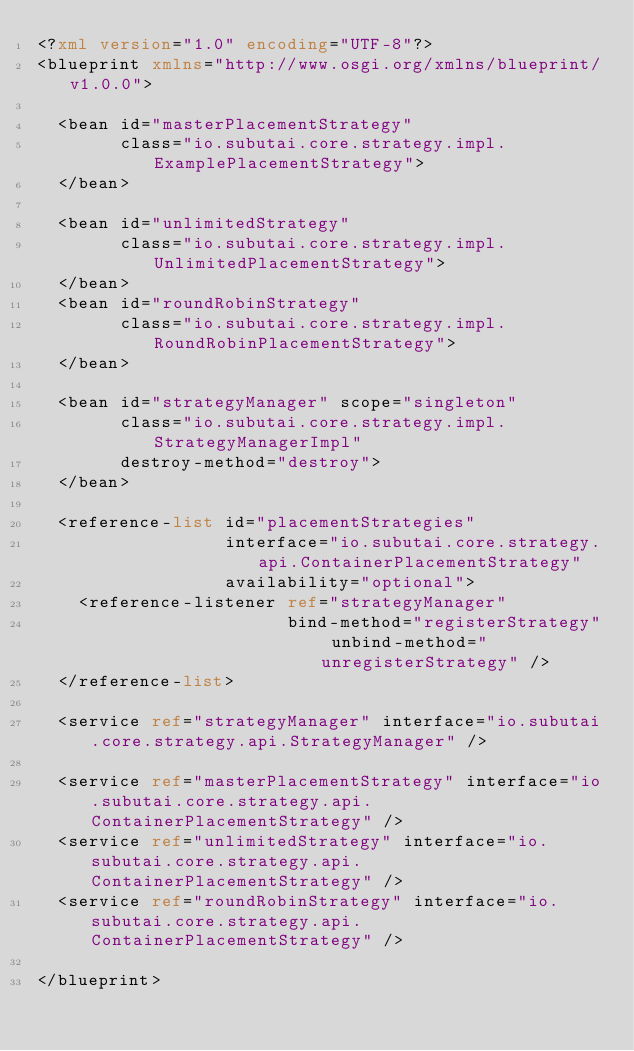Convert code to text. <code><loc_0><loc_0><loc_500><loc_500><_XML_><?xml version="1.0" encoding="UTF-8"?>
<blueprint xmlns="http://www.osgi.org/xmlns/blueprint/v1.0.0">

  <bean id="masterPlacementStrategy"
        class="io.subutai.core.strategy.impl.ExamplePlacementStrategy">
  </bean>

  <bean id="unlimitedStrategy"
        class="io.subutai.core.strategy.impl.UnlimitedPlacementStrategy">
  </bean>
  <bean id="roundRobinStrategy"
        class="io.subutai.core.strategy.impl.RoundRobinPlacementStrategy">
  </bean>

  <bean id="strategyManager" scope="singleton"
        class="io.subutai.core.strategy.impl.StrategyManagerImpl"
        destroy-method="destroy">
  </bean>

  <reference-list id="placementStrategies"
                  interface="io.subutai.core.strategy.api.ContainerPlacementStrategy"
                  availability="optional">
    <reference-listener ref="strategyManager"
                        bind-method="registerStrategy" unbind-method="unregisterStrategy" />
  </reference-list>

  <service ref="strategyManager" interface="io.subutai.core.strategy.api.StrategyManager" />

  <service ref="masterPlacementStrategy" interface="io.subutai.core.strategy.api.ContainerPlacementStrategy" />
  <service ref="unlimitedStrategy" interface="io.subutai.core.strategy.api.ContainerPlacementStrategy" />
  <service ref="roundRobinStrategy" interface="io.subutai.core.strategy.api.ContainerPlacementStrategy" />

</blueprint>
</code> 